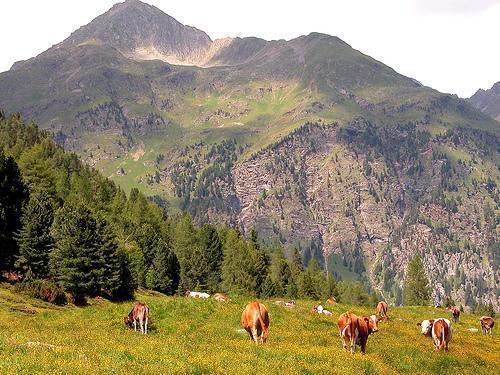How many species can be seen here of mammals?
Indicate the correct response by choosing from the four available options to answer the question.
Options: One, four, five, nine. One. 